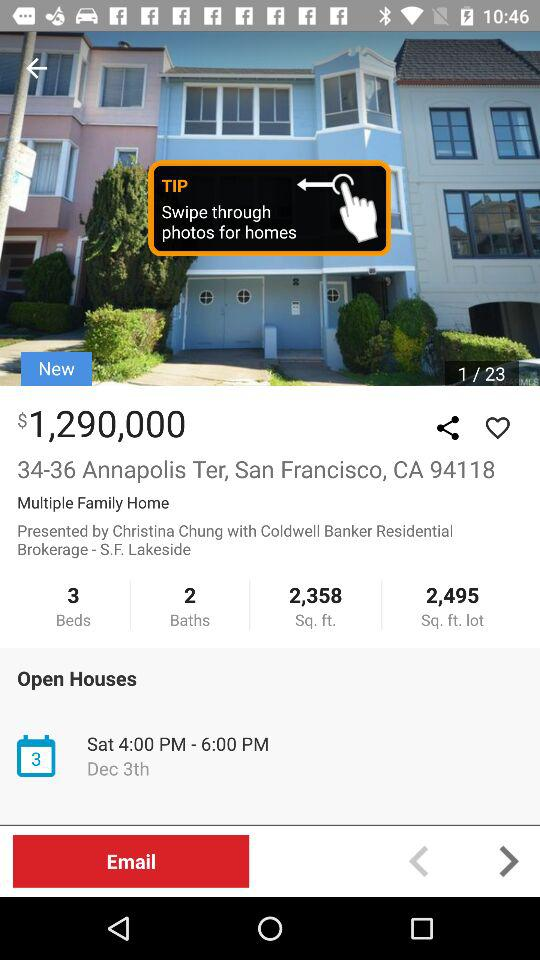How many baths does the home have?
Answer the question using a single word or phrase. 2 